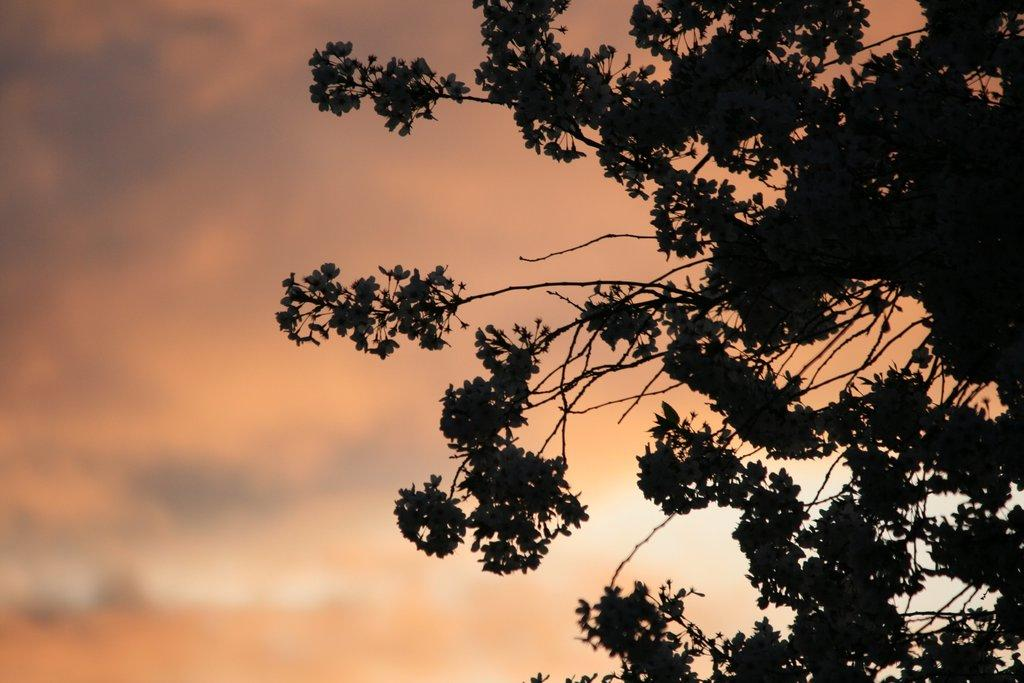What type of vegetation can be seen in the background of the image? There is a tree in the background of the image. What else is visible in the background of the image? The sky is visible in the background of the image. How many fans can be seen hanging from the tree in the image? There are no fans present in the image; it features a tree and the sky in the background. What type of spiders can be seen crawling on the tree in the image? There are no spiders present in the image; it features a tree and the sky in the background. 